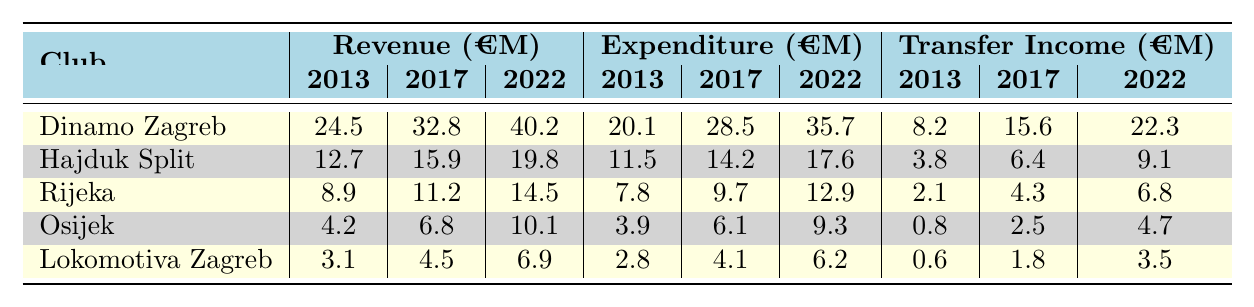What was the total revenue for Dinamo Zagreb in 2022? According to the table, the revenue for Dinamo Zagreb in 2022 is listed as €40.2M.
Answer: €40.2M How much did Hajduk Split spend in 2013? The table indicates that Hajduk Split's expenditure in 2013 was €11.5M.
Answer: €11.5M What is the average transfer income for Rijeka over the years 2013, 2017, and 2022? The transfer incomes are €2.1M (2013), €4.3M (2017), and €6.8M (2022). Summing these gives €2.1 + €4.3 + €6.8 = €13.2M. Dividing by 3 gives an average of €13.2M / 3 = €4.4M.
Answer: €4.4M Did Osijek's revenue increase from 2013 to 2022? The revenue for Osijek was €4.2M in 2013 and €10.1M in 2022. Since €10.1M is greater than €4.2M, the revenue did increase.
Answer: Yes Which club had the highest transfer income in 2022? The transfer incomes for 2022 are €22.3M for Dinamo Zagreb, €9.1M for Hajduk Split, €6.8M for Rijeka, €4.7M for Osijek, and €3.5M for Lokomotiva Zagreb. The highest value is €22.3M from Dinamo Zagreb.
Answer: Dinamo Zagreb What was the total expenditure for Hajduk Split from 2013 to 2022? The expenditures for Hajduk Split are €11.5M (2013), €14.2M (2017), and €17.6M (2022). Summing these gives €11.5 + €14.2 + €17.6 = €43.3M.
Answer: €43.3M How much did Lokomotiva Zagreb earn from transfers in 2017? The table shows Lokomotiva Zagreb's transfer income for 2017 was €1.8M.
Answer: €1.8M Is the increase in revenue for Dinamo Zagreb from 2017 to 2022 greater than €5M? The revenue in 2017 was €32.8M and in 2022 it was €40.2M. The increase is €40.2M - €32.8M = €7.4M, which is greater than €5M.
Answer: Yes What is the difference in revenue between Rijeka and Osijek in 2022? The revenue for Rijeka in 2022 is €14.5M and for Osijek it is €10.1M. The difference is €14.5M - €10.1M = €4.4M.
Answer: €4.4M 